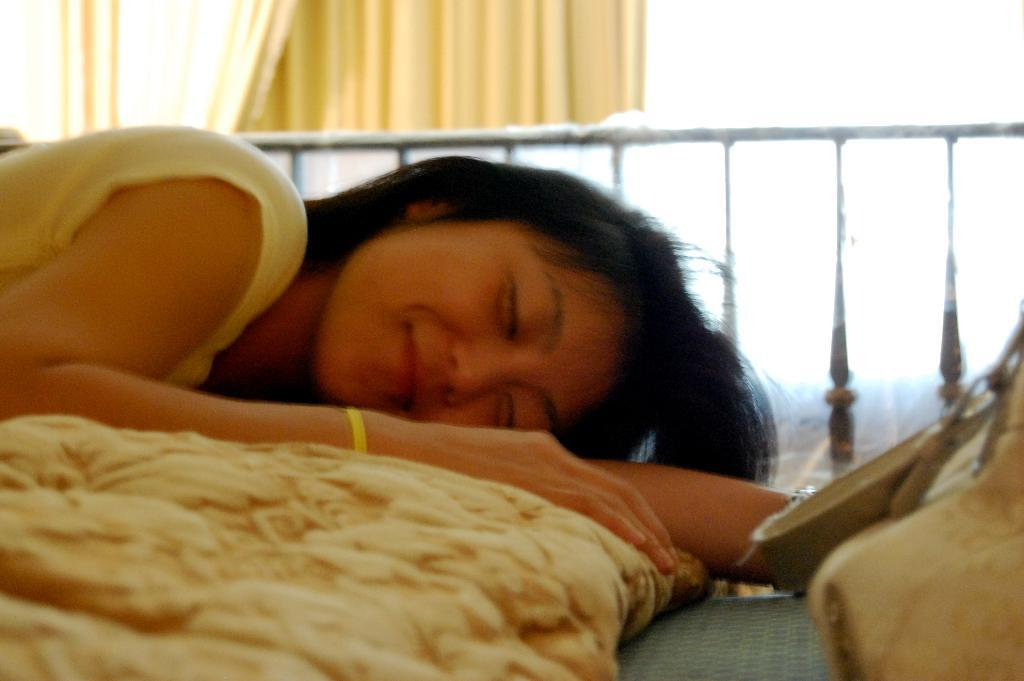Who is present in the image? There is a woman in the image. What is the woman doing in the image? The woman is laying on a bed. What can be seen in the background of the image? There is a curtain in the image. How is the woman's facial expression in the image? The woman is holding a smile. How much wealth does the woman possess in the image? There is no information about the woman's wealth in the image. What type of sheet is covering the bed in the image? The image does not show any sheets covering the bed. 